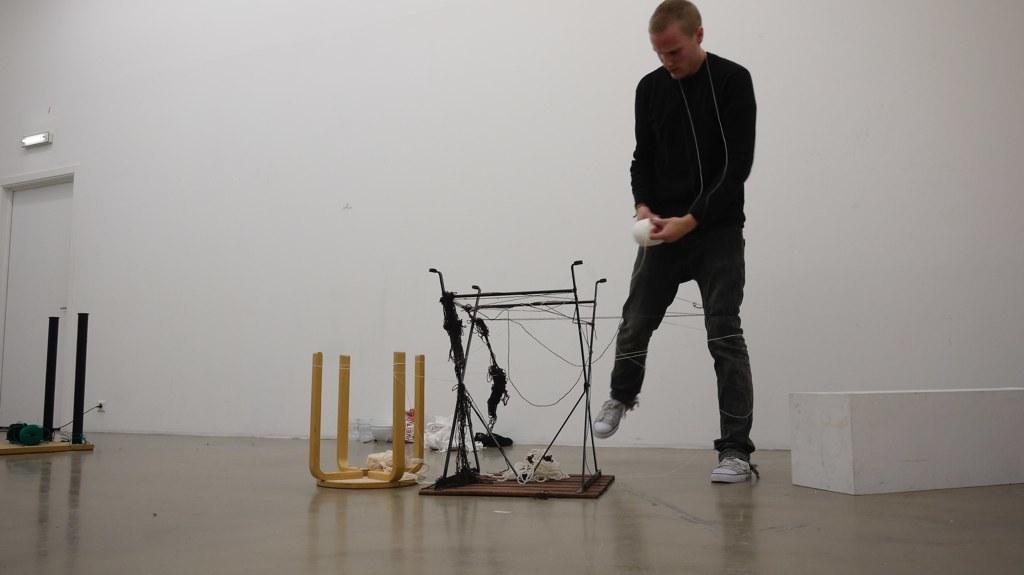Could you give a brief overview of what you see in this image? On the right side, there is a person in a black color t-shirt, holding a thread bundle with a hand and on the floor. In front of him, there are two steels arranged in reverse position on the floor and there is a white color box on the floor. On the left side, there is another stool arranged in reverse position on the floor. In the background, there is a white color door and there is a light attached to the white wall. 